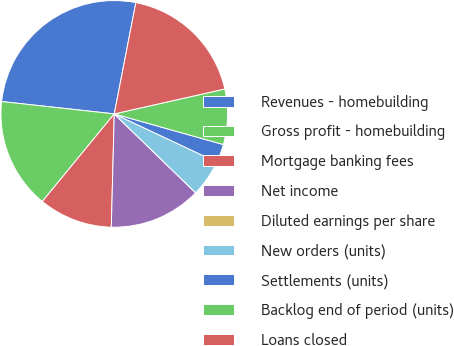Convert chart. <chart><loc_0><loc_0><loc_500><loc_500><pie_chart><fcel>Revenues - homebuilding<fcel>Gross profit - homebuilding<fcel>Mortgage banking fees<fcel>Net income<fcel>Diluted earnings per share<fcel>New orders (units)<fcel>Settlements (units)<fcel>Backlog end of period (units)<fcel>Loans closed<nl><fcel>26.31%<fcel>15.79%<fcel>10.53%<fcel>13.16%<fcel>0.0%<fcel>5.26%<fcel>2.63%<fcel>7.89%<fcel>18.42%<nl></chart> 